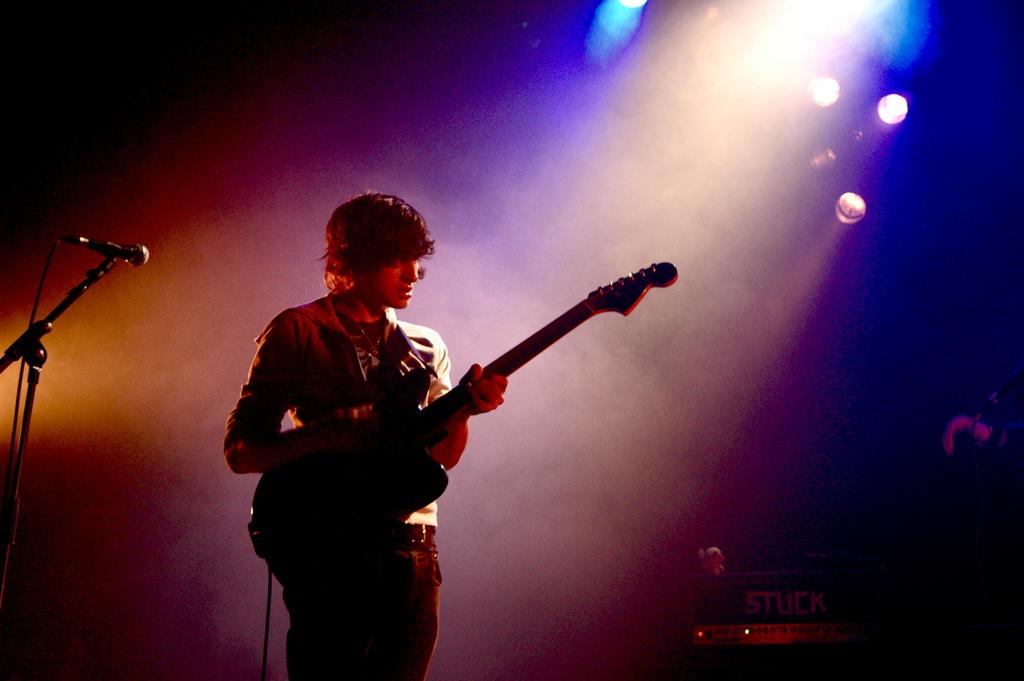What is the man in the image doing? The man is playing a guitar in the image. What object is present that is commonly used for amplifying sound? There is a microphone in the image. How does the man say good-bye to his brother in the image? There is no indication of a brother or any good-byes in the image; the man is simply playing a guitar. 